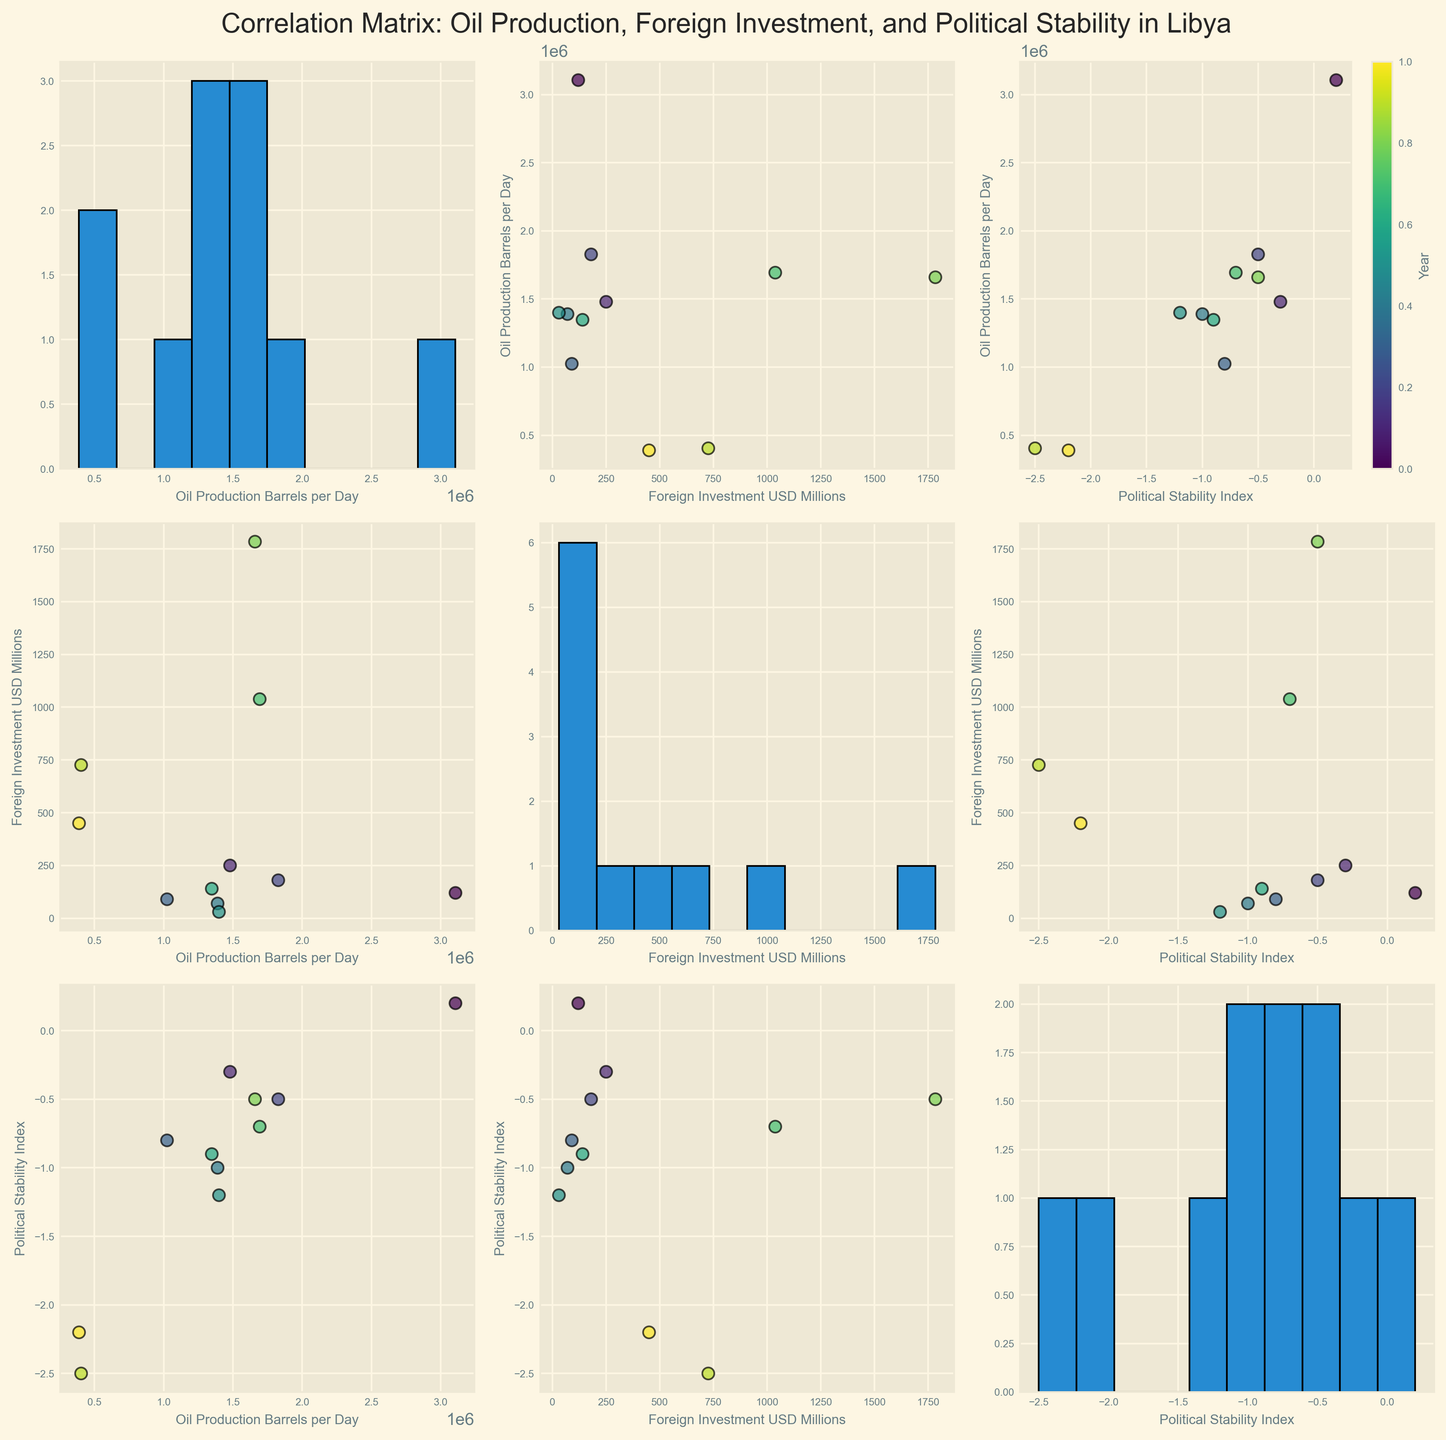How many data points are representing the year 2010? The scatterplot matrix uses the color to represent the year of each data point. By looking at the colorbar and identifying the color for the year 2010, you can count the number of data points with that color in all scatter plots.
Answer: 1 What general trend is observed between Oil Production and Political Stability? By examining the scatter plot where Oil Production is on one axis and Political Stability on the other, we notice that as Political Stability decreases (more negative), Oil Production also tends to decrease.
Answer: Negative correlation Which year had the highest foreign investment? From the scatter plot matrix, we can identify the year with the highest Foreign Investment by looking at the point with the highest value on the axis representing Foreign Investment. The color of this point indicates the year.
Answer: 2010 What is the relationship between Foreign Investment and Political Stability? By viewing the scatter plot where Foreign Investment is on one axis and Political Stability on the other, we see how values of Foreign Investment correlate with changes in Political Stability. A general pattern or trend can clarify their relationship.
Answer: Negative correlation How has oil production changed from 1970 to 2020 in terms of trends? By referring to the specific scatterplot and histogram for Oil Production, we can observe the overall trend and individual changes in oil production from 1970 through to 2020. Each point represents a distinct year, and the time series allows us to visualize increases or decreases over time.
Answer: Decrease Are there any years where Foreign Investment rises despite a drop in Political Stability? By looking at the scatter plot of Foreign Investment versus Political Stability, and noting the years by their corresponding colors, we can identify if there are any years that stand out with increasing investment but decreasing stability.
Answer: Yes Does the trend of Political Stability display any notable shifts or outliers in its histogram? By examining the histogram of Political Stability, we can identify the distribution of data points and observe any outliers or significant shifts in trends over the years.
Answer: Yes, 2015-2020 noticeable drop Which variable between Oil Production and Foreign Investment shows greater spread over 50 years? By comparing the histograms of Oil Production and Foreign Investment, we can visualize and compare the variability or spread of data points over the time period.
Answer: Foreign Investment How does Political Stability Index correlate with Foreign Investment over the provided years? Observing the scatter plot that correlates Political Stability Index and Foreign Investment, focusing on the overall trend or pattern, we can deduce whether an increase/decrease in stability is generally accompanied by an increase/decrease in investment.
Answer: Negative correlation 